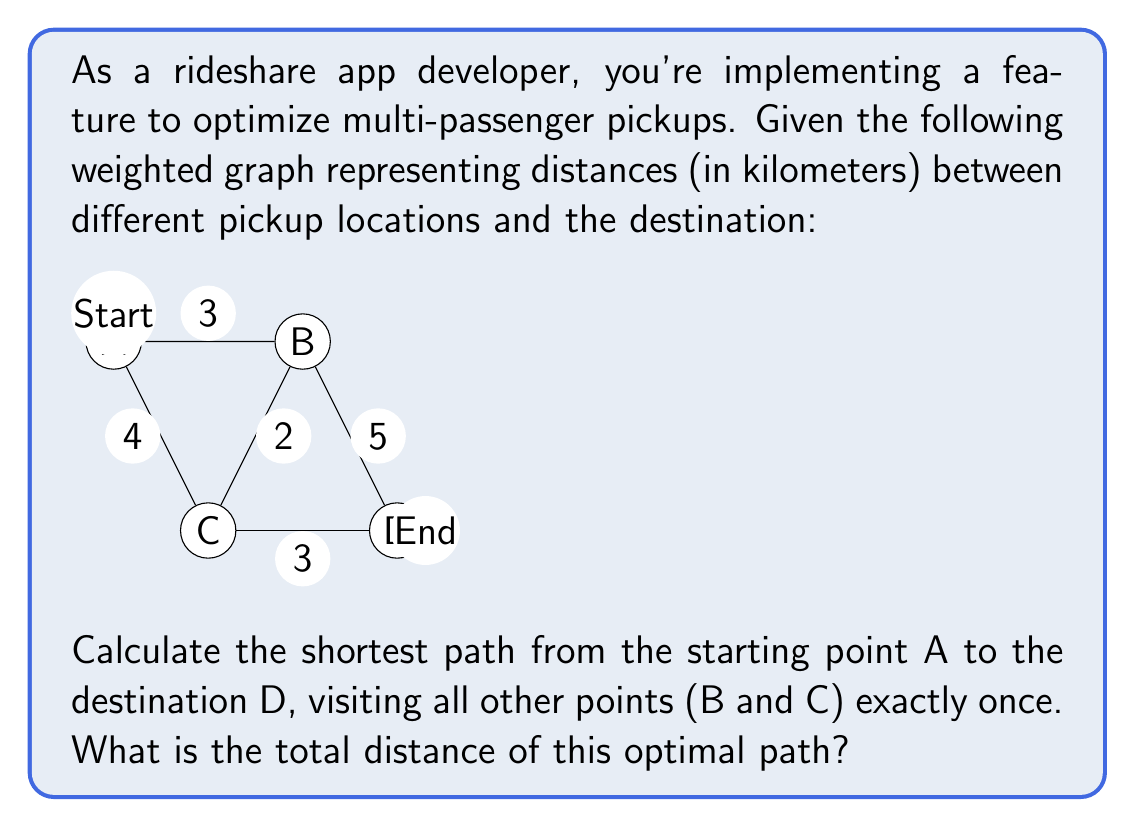Can you solve this math problem? To solve this problem, we'll use the concept of the Traveling Salesman Problem (TSP) from graph theory, which is applicable to finding the shortest path that visits all nodes in a graph exactly once.

Given:
- Start at A
- End at D
- Must visit B and C exactly once
- Distances: AB = 3, AC = 4, BC = 2, BD = 5, CD = 3

Steps:
1) List all possible paths from A to D visiting B and C:
   - A -> B -> C -> D
   - A -> C -> B -> D

2) Calculate the total distance for each path:

   Path 1: A -> B -> C -> D
   $$d_1 = d_{AB} + d_{BC} + d_{CD} = 3 + 2 + 3 = 8\text{ km}$$

   Path 2: A -> C -> B -> D
   $$d_2 = d_{AC} + d_{CB} + d_{BD} = 4 + 2 + 5 = 11\text{ km}$$

3) Compare the total distances:
   Path 1 (8 km) is shorter than Path 2 (11 km)

Therefore, the optimal path is A -> B -> C -> D, with a total distance of 8 km.
Answer: The shortest path from A to D, visiting B and C exactly once, is A -> B -> C -> D, with a total distance of 8 km. 